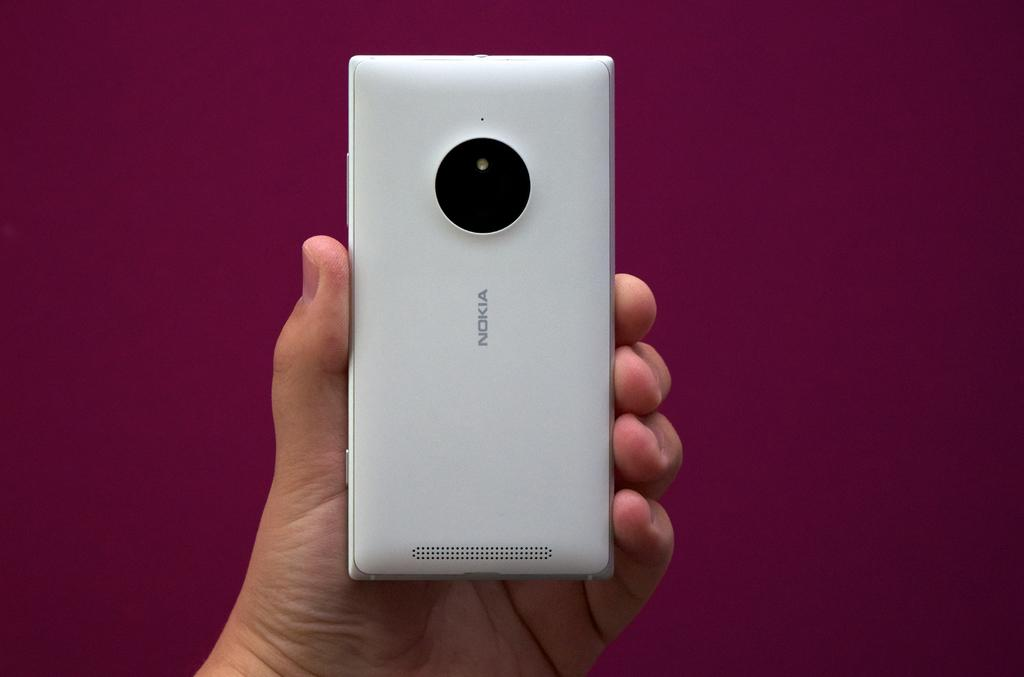Provide a one-sentence caption for the provided image. A hand holding up a Nokia device with a purple background. 